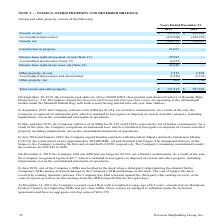According to Overseas Shipholding Group's financial document, When did the Company sold one ATB and one barge for $2,367? According to the financial document, December 6, 2018. The relevant text states: "On December 6, 2018, the Company sold one ATB and one barge for $2,367, net of broker commissions. As a result of the s..." Also, can you calculate: What is the change in Total vessels and other property from Years Ended December 31, 2018 to 2019? Based on the calculation: 737,212-597,659, the result is 139553. This is based on the information: "Total vessels and other property $ 737,212 $ 597,659 Total vessels and other property $ 737,212 $ 597,659..." The key data points involved are: 597,659, 737,212. Also, can you calculate: What is the average Total vessels and other property for Years Ended December 31, 2018 to 2019? To answer this question, I need to perform calculations using the financial data. The calculation is: (737,212+597,659) / 2, which equals 667435.5. This is based on the information: "Total vessels and other property $ 737,212 $ 597,659 Total vessels and other property $ 737,212 $ 597,659..." The key data points involved are: 597,659, 737,212. Additionally, In which year was Vessels, at cost less than 900,000? According to the financial document, 2018. The relevant text states: "2019 2018..." Also, What was the value of Vessels, net in 2019 and 2018 respectively? The document shows two values: 644,312 and 596,929. From the document: "Vessels, net 644,312 596,929 Vessels, net 644,312 596,929..." Also, When did the company take the delivery of two 50,000 DWT class products? According to the financial document, September 30, 2019. The relevant text states: "On September 30, 2019, the Company took delivery of two 50,000 DWT class product and chemical tankers at Hyundai Mipo Doc..." 